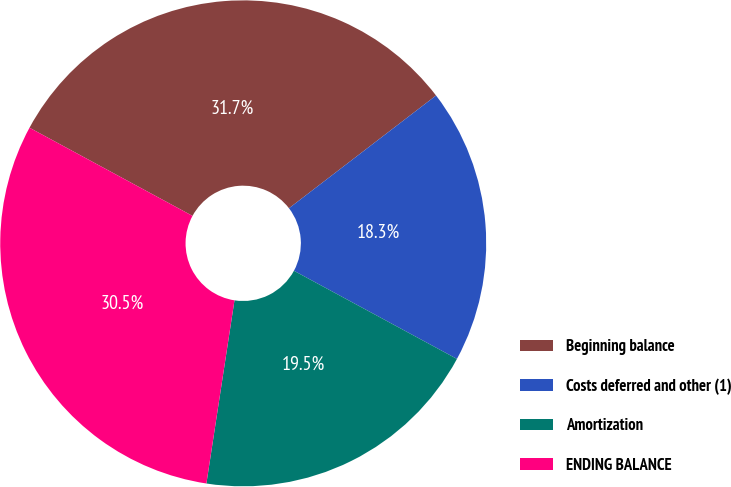Convert chart. <chart><loc_0><loc_0><loc_500><loc_500><pie_chart><fcel>Beginning balance<fcel>Costs deferred and other (1)<fcel>Amortization<fcel>ENDING BALANCE<nl><fcel>31.7%<fcel>18.3%<fcel>19.53%<fcel>30.47%<nl></chart> 